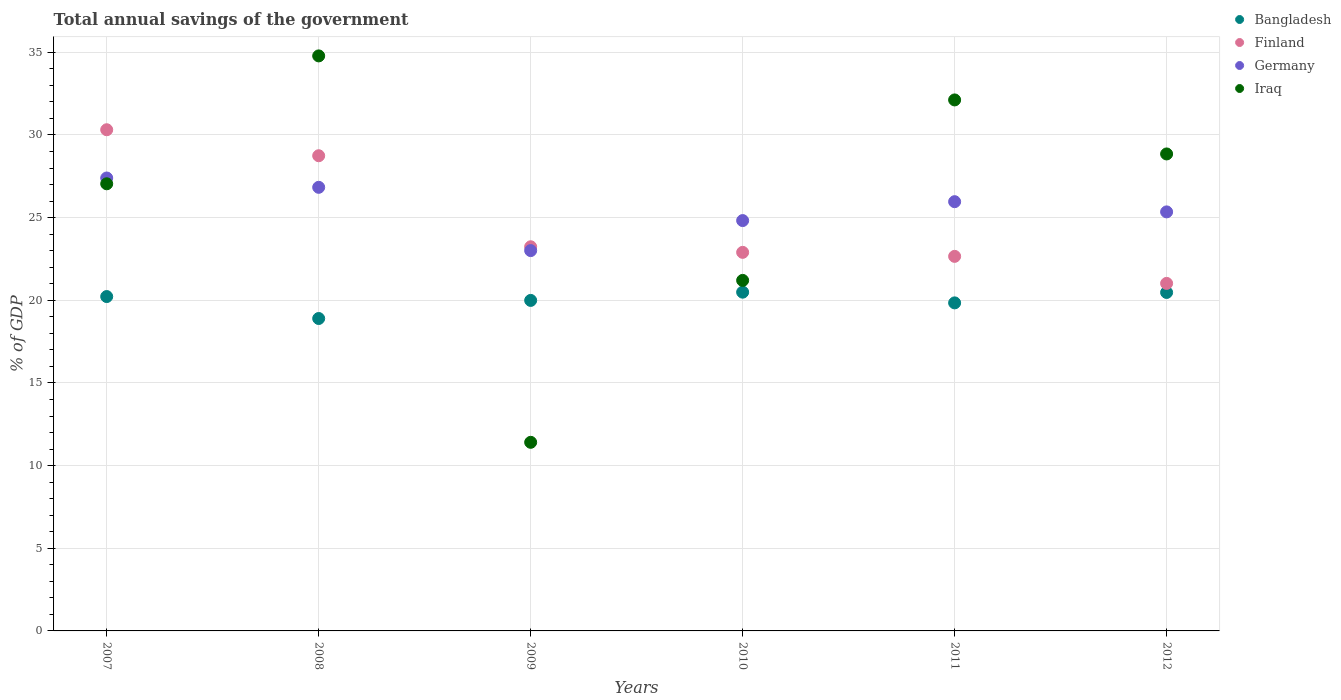How many different coloured dotlines are there?
Offer a very short reply. 4. What is the total annual savings of the government in Finland in 2008?
Your response must be concise. 28.75. Across all years, what is the maximum total annual savings of the government in Iraq?
Your answer should be very brief. 34.79. Across all years, what is the minimum total annual savings of the government in Bangladesh?
Keep it short and to the point. 18.9. In which year was the total annual savings of the government in Bangladesh minimum?
Your response must be concise. 2008. What is the total total annual savings of the government in Iraq in the graph?
Make the answer very short. 155.42. What is the difference between the total annual savings of the government in Bangladesh in 2008 and that in 2010?
Offer a terse response. -1.59. What is the difference between the total annual savings of the government in Iraq in 2010 and the total annual savings of the government in Finland in 2008?
Offer a very short reply. -7.54. What is the average total annual savings of the government in Bangladesh per year?
Ensure brevity in your answer.  19.99. In the year 2010, what is the difference between the total annual savings of the government in Finland and total annual savings of the government in Iraq?
Offer a terse response. 1.7. In how many years, is the total annual savings of the government in Iraq greater than 13 %?
Provide a succinct answer. 5. What is the ratio of the total annual savings of the government in Iraq in 2008 to that in 2010?
Give a very brief answer. 1.64. What is the difference between the highest and the second highest total annual savings of the government in Iraq?
Provide a short and direct response. 2.66. What is the difference between the highest and the lowest total annual savings of the government in Finland?
Offer a very short reply. 9.29. How many years are there in the graph?
Your answer should be very brief. 6. Where does the legend appear in the graph?
Provide a succinct answer. Top right. What is the title of the graph?
Your response must be concise. Total annual savings of the government. Does "Fragile and conflict affected situations" appear as one of the legend labels in the graph?
Make the answer very short. No. What is the label or title of the X-axis?
Your answer should be very brief. Years. What is the label or title of the Y-axis?
Make the answer very short. % of GDP. What is the % of GDP in Bangladesh in 2007?
Keep it short and to the point. 20.23. What is the % of GDP in Finland in 2007?
Ensure brevity in your answer.  30.32. What is the % of GDP in Germany in 2007?
Give a very brief answer. 27.4. What is the % of GDP of Iraq in 2007?
Offer a terse response. 27.05. What is the % of GDP of Bangladesh in 2008?
Your answer should be very brief. 18.9. What is the % of GDP in Finland in 2008?
Ensure brevity in your answer.  28.75. What is the % of GDP in Germany in 2008?
Ensure brevity in your answer.  26.83. What is the % of GDP in Iraq in 2008?
Offer a very short reply. 34.79. What is the % of GDP of Bangladesh in 2009?
Make the answer very short. 19.99. What is the % of GDP of Finland in 2009?
Provide a succinct answer. 23.24. What is the % of GDP of Germany in 2009?
Your answer should be compact. 23.01. What is the % of GDP in Iraq in 2009?
Your answer should be compact. 11.41. What is the % of GDP in Bangladesh in 2010?
Give a very brief answer. 20.49. What is the % of GDP of Finland in 2010?
Keep it short and to the point. 22.9. What is the % of GDP of Germany in 2010?
Keep it short and to the point. 24.82. What is the % of GDP in Iraq in 2010?
Provide a short and direct response. 21.2. What is the % of GDP in Bangladesh in 2011?
Your answer should be very brief. 19.84. What is the % of GDP in Finland in 2011?
Make the answer very short. 22.66. What is the % of GDP of Germany in 2011?
Offer a terse response. 25.97. What is the % of GDP of Iraq in 2011?
Offer a very short reply. 32.12. What is the % of GDP of Bangladesh in 2012?
Provide a short and direct response. 20.47. What is the % of GDP in Finland in 2012?
Offer a very short reply. 21.02. What is the % of GDP of Germany in 2012?
Ensure brevity in your answer.  25.35. What is the % of GDP of Iraq in 2012?
Your answer should be very brief. 28.85. Across all years, what is the maximum % of GDP of Bangladesh?
Offer a very short reply. 20.49. Across all years, what is the maximum % of GDP of Finland?
Make the answer very short. 30.32. Across all years, what is the maximum % of GDP in Germany?
Offer a very short reply. 27.4. Across all years, what is the maximum % of GDP of Iraq?
Give a very brief answer. 34.79. Across all years, what is the minimum % of GDP in Bangladesh?
Ensure brevity in your answer.  18.9. Across all years, what is the minimum % of GDP in Finland?
Give a very brief answer. 21.02. Across all years, what is the minimum % of GDP in Germany?
Make the answer very short. 23.01. Across all years, what is the minimum % of GDP in Iraq?
Provide a short and direct response. 11.41. What is the total % of GDP in Bangladesh in the graph?
Your answer should be very brief. 119.93. What is the total % of GDP of Finland in the graph?
Your answer should be very brief. 148.88. What is the total % of GDP of Germany in the graph?
Offer a terse response. 153.38. What is the total % of GDP in Iraq in the graph?
Offer a very short reply. 155.42. What is the difference between the % of GDP of Bangladesh in 2007 and that in 2008?
Provide a succinct answer. 1.33. What is the difference between the % of GDP in Finland in 2007 and that in 2008?
Provide a succinct answer. 1.57. What is the difference between the % of GDP in Germany in 2007 and that in 2008?
Keep it short and to the point. 0.56. What is the difference between the % of GDP in Iraq in 2007 and that in 2008?
Provide a short and direct response. -7.74. What is the difference between the % of GDP of Bangladesh in 2007 and that in 2009?
Your answer should be very brief. 0.23. What is the difference between the % of GDP in Finland in 2007 and that in 2009?
Ensure brevity in your answer.  7.08. What is the difference between the % of GDP in Germany in 2007 and that in 2009?
Your answer should be very brief. 4.39. What is the difference between the % of GDP of Iraq in 2007 and that in 2009?
Your answer should be very brief. 15.64. What is the difference between the % of GDP of Bangladesh in 2007 and that in 2010?
Your response must be concise. -0.27. What is the difference between the % of GDP in Finland in 2007 and that in 2010?
Offer a very short reply. 7.42. What is the difference between the % of GDP in Germany in 2007 and that in 2010?
Your response must be concise. 2.58. What is the difference between the % of GDP of Iraq in 2007 and that in 2010?
Offer a very short reply. 5.84. What is the difference between the % of GDP of Bangladesh in 2007 and that in 2011?
Your answer should be compact. 0.38. What is the difference between the % of GDP of Finland in 2007 and that in 2011?
Make the answer very short. 7.66. What is the difference between the % of GDP of Germany in 2007 and that in 2011?
Your answer should be very brief. 1.43. What is the difference between the % of GDP of Iraq in 2007 and that in 2011?
Make the answer very short. -5.07. What is the difference between the % of GDP in Bangladesh in 2007 and that in 2012?
Your answer should be very brief. -0.25. What is the difference between the % of GDP of Finland in 2007 and that in 2012?
Ensure brevity in your answer.  9.29. What is the difference between the % of GDP in Germany in 2007 and that in 2012?
Provide a succinct answer. 2.05. What is the difference between the % of GDP in Iraq in 2007 and that in 2012?
Give a very brief answer. -1.81. What is the difference between the % of GDP in Bangladesh in 2008 and that in 2009?
Provide a short and direct response. -1.09. What is the difference between the % of GDP in Finland in 2008 and that in 2009?
Provide a succinct answer. 5.51. What is the difference between the % of GDP of Germany in 2008 and that in 2009?
Provide a short and direct response. 3.83. What is the difference between the % of GDP of Iraq in 2008 and that in 2009?
Offer a very short reply. 23.38. What is the difference between the % of GDP of Bangladesh in 2008 and that in 2010?
Your answer should be compact. -1.59. What is the difference between the % of GDP in Finland in 2008 and that in 2010?
Offer a terse response. 5.84. What is the difference between the % of GDP of Germany in 2008 and that in 2010?
Provide a succinct answer. 2.01. What is the difference between the % of GDP of Iraq in 2008 and that in 2010?
Your response must be concise. 13.58. What is the difference between the % of GDP of Bangladesh in 2008 and that in 2011?
Provide a short and direct response. -0.95. What is the difference between the % of GDP in Finland in 2008 and that in 2011?
Your response must be concise. 6.09. What is the difference between the % of GDP in Germany in 2008 and that in 2011?
Offer a terse response. 0.87. What is the difference between the % of GDP in Iraq in 2008 and that in 2011?
Make the answer very short. 2.66. What is the difference between the % of GDP in Bangladesh in 2008 and that in 2012?
Your answer should be compact. -1.58. What is the difference between the % of GDP in Finland in 2008 and that in 2012?
Your answer should be compact. 7.72. What is the difference between the % of GDP of Germany in 2008 and that in 2012?
Offer a very short reply. 1.49. What is the difference between the % of GDP of Iraq in 2008 and that in 2012?
Offer a terse response. 5.93. What is the difference between the % of GDP of Bangladesh in 2009 and that in 2010?
Offer a terse response. -0.5. What is the difference between the % of GDP in Finland in 2009 and that in 2010?
Give a very brief answer. 0.34. What is the difference between the % of GDP in Germany in 2009 and that in 2010?
Make the answer very short. -1.82. What is the difference between the % of GDP in Iraq in 2009 and that in 2010?
Offer a terse response. -9.79. What is the difference between the % of GDP in Bangladesh in 2009 and that in 2011?
Your answer should be very brief. 0.15. What is the difference between the % of GDP in Finland in 2009 and that in 2011?
Your answer should be very brief. 0.58. What is the difference between the % of GDP of Germany in 2009 and that in 2011?
Provide a short and direct response. -2.96. What is the difference between the % of GDP in Iraq in 2009 and that in 2011?
Make the answer very short. -20.71. What is the difference between the % of GDP in Bangladesh in 2009 and that in 2012?
Ensure brevity in your answer.  -0.48. What is the difference between the % of GDP of Finland in 2009 and that in 2012?
Your answer should be compact. 2.21. What is the difference between the % of GDP in Germany in 2009 and that in 2012?
Provide a short and direct response. -2.34. What is the difference between the % of GDP in Iraq in 2009 and that in 2012?
Offer a terse response. -17.44. What is the difference between the % of GDP of Bangladesh in 2010 and that in 2011?
Provide a short and direct response. 0.65. What is the difference between the % of GDP of Finland in 2010 and that in 2011?
Make the answer very short. 0.24. What is the difference between the % of GDP of Germany in 2010 and that in 2011?
Your response must be concise. -1.14. What is the difference between the % of GDP in Iraq in 2010 and that in 2011?
Your answer should be very brief. -10.92. What is the difference between the % of GDP in Bangladesh in 2010 and that in 2012?
Give a very brief answer. 0.02. What is the difference between the % of GDP in Finland in 2010 and that in 2012?
Your answer should be very brief. 1.88. What is the difference between the % of GDP in Germany in 2010 and that in 2012?
Your answer should be compact. -0.53. What is the difference between the % of GDP in Iraq in 2010 and that in 2012?
Your response must be concise. -7.65. What is the difference between the % of GDP of Bangladesh in 2011 and that in 2012?
Offer a terse response. -0.63. What is the difference between the % of GDP in Finland in 2011 and that in 2012?
Ensure brevity in your answer.  1.64. What is the difference between the % of GDP in Germany in 2011 and that in 2012?
Ensure brevity in your answer.  0.62. What is the difference between the % of GDP in Iraq in 2011 and that in 2012?
Give a very brief answer. 3.27. What is the difference between the % of GDP in Bangladesh in 2007 and the % of GDP in Finland in 2008?
Your response must be concise. -8.52. What is the difference between the % of GDP of Bangladesh in 2007 and the % of GDP of Germany in 2008?
Offer a very short reply. -6.61. What is the difference between the % of GDP of Bangladesh in 2007 and the % of GDP of Iraq in 2008?
Ensure brevity in your answer.  -14.56. What is the difference between the % of GDP in Finland in 2007 and the % of GDP in Germany in 2008?
Your response must be concise. 3.48. What is the difference between the % of GDP in Finland in 2007 and the % of GDP in Iraq in 2008?
Offer a terse response. -4.47. What is the difference between the % of GDP in Germany in 2007 and the % of GDP in Iraq in 2008?
Provide a short and direct response. -7.39. What is the difference between the % of GDP of Bangladesh in 2007 and the % of GDP of Finland in 2009?
Make the answer very short. -3.01. What is the difference between the % of GDP of Bangladesh in 2007 and the % of GDP of Germany in 2009?
Your answer should be very brief. -2.78. What is the difference between the % of GDP of Bangladesh in 2007 and the % of GDP of Iraq in 2009?
Provide a succinct answer. 8.82. What is the difference between the % of GDP of Finland in 2007 and the % of GDP of Germany in 2009?
Provide a succinct answer. 7.31. What is the difference between the % of GDP of Finland in 2007 and the % of GDP of Iraq in 2009?
Keep it short and to the point. 18.91. What is the difference between the % of GDP of Germany in 2007 and the % of GDP of Iraq in 2009?
Your answer should be very brief. 15.99. What is the difference between the % of GDP of Bangladesh in 2007 and the % of GDP of Finland in 2010?
Ensure brevity in your answer.  -2.67. What is the difference between the % of GDP of Bangladesh in 2007 and the % of GDP of Germany in 2010?
Ensure brevity in your answer.  -4.6. What is the difference between the % of GDP of Bangladesh in 2007 and the % of GDP of Iraq in 2010?
Your answer should be compact. -0.98. What is the difference between the % of GDP of Finland in 2007 and the % of GDP of Germany in 2010?
Offer a very short reply. 5.49. What is the difference between the % of GDP of Finland in 2007 and the % of GDP of Iraq in 2010?
Make the answer very short. 9.11. What is the difference between the % of GDP in Germany in 2007 and the % of GDP in Iraq in 2010?
Offer a terse response. 6.19. What is the difference between the % of GDP of Bangladesh in 2007 and the % of GDP of Finland in 2011?
Provide a succinct answer. -2.43. What is the difference between the % of GDP of Bangladesh in 2007 and the % of GDP of Germany in 2011?
Keep it short and to the point. -5.74. What is the difference between the % of GDP of Bangladesh in 2007 and the % of GDP of Iraq in 2011?
Ensure brevity in your answer.  -11.89. What is the difference between the % of GDP of Finland in 2007 and the % of GDP of Germany in 2011?
Offer a terse response. 4.35. What is the difference between the % of GDP in Finland in 2007 and the % of GDP in Iraq in 2011?
Make the answer very short. -1.8. What is the difference between the % of GDP in Germany in 2007 and the % of GDP in Iraq in 2011?
Offer a terse response. -4.72. What is the difference between the % of GDP of Bangladesh in 2007 and the % of GDP of Finland in 2012?
Your answer should be compact. -0.8. What is the difference between the % of GDP of Bangladesh in 2007 and the % of GDP of Germany in 2012?
Your answer should be very brief. -5.12. What is the difference between the % of GDP of Bangladesh in 2007 and the % of GDP of Iraq in 2012?
Give a very brief answer. -8.63. What is the difference between the % of GDP in Finland in 2007 and the % of GDP in Germany in 2012?
Offer a terse response. 4.97. What is the difference between the % of GDP in Finland in 2007 and the % of GDP in Iraq in 2012?
Offer a very short reply. 1.46. What is the difference between the % of GDP of Germany in 2007 and the % of GDP of Iraq in 2012?
Your answer should be compact. -1.46. What is the difference between the % of GDP of Bangladesh in 2008 and the % of GDP of Finland in 2009?
Provide a short and direct response. -4.34. What is the difference between the % of GDP of Bangladesh in 2008 and the % of GDP of Germany in 2009?
Provide a succinct answer. -4.11. What is the difference between the % of GDP of Bangladesh in 2008 and the % of GDP of Iraq in 2009?
Provide a short and direct response. 7.49. What is the difference between the % of GDP of Finland in 2008 and the % of GDP of Germany in 2009?
Your answer should be compact. 5.74. What is the difference between the % of GDP of Finland in 2008 and the % of GDP of Iraq in 2009?
Provide a succinct answer. 17.34. What is the difference between the % of GDP in Germany in 2008 and the % of GDP in Iraq in 2009?
Keep it short and to the point. 15.43. What is the difference between the % of GDP in Bangladesh in 2008 and the % of GDP in Finland in 2010?
Give a very brief answer. -4. What is the difference between the % of GDP in Bangladesh in 2008 and the % of GDP in Germany in 2010?
Provide a succinct answer. -5.92. What is the difference between the % of GDP in Bangladesh in 2008 and the % of GDP in Iraq in 2010?
Your response must be concise. -2.31. What is the difference between the % of GDP of Finland in 2008 and the % of GDP of Germany in 2010?
Provide a short and direct response. 3.92. What is the difference between the % of GDP in Finland in 2008 and the % of GDP in Iraq in 2010?
Make the answer very short. 7.54. What is the difference between the % of GDP of Germany in 2008 and the % of GDP of Iraq in 2010?
Ensure brevity in your answer.  5.63. What is the difference between the % of GDP in Bangladesh in 2008 and the % of GDP in Finland in 2011?
Provide a short and direct response. -3.76. What is the difference between the % of GDP of Bangladesh in 2008 and the % of GDP of Germany in 2011?
Provide a succinct answer. -7.07. What is the difference between the % of GDP of Bangladesh in 2008 and the % of GDP of Iraq in 2011?
Your answer should be compact. -13.22. What is the difference between the % of GDP in Finland in 2008 and the % of GDP in Germany in 2011?
Make the answer very short. 2.78. What is the difference between the % of GDP of Finland in 2008 and the % of GDP of Iraq in 2011?
Offer a very short reply. -3.38. What is the difference between the % of GDP in Germany in 2008 and the % of GDP in Iraq in 2011?
Your answer should be compact. -5.29. What is the difference between the % of GDP of Bangladesh in 2008 and the % of GDP of Finland in 2012?
Your response must be concise. -2.12. What is the difference between the % of GDP in Bangladesh in 2008 and the % of GDP in Germany in 2012?
Provide a succinct answer. -6.45. What is the difference between the % of GDP of Bangladesh in 2008 and the % of GDP of Iraq in 2012?
Your answer should be very brief. -9.95. What is the difference between the % of GDP of Finland in 2008 and the % of GDP of Germany in 2012?
Make the answer very short. 3.4. What is the difference between the % of GDP of Finland in 2008 and the % of GDP of Iraq in 2012?
Keep it short and to the point. -0.11. What is the difference between the % of GDP of Germany in 2008 and the % of GDP of Iraq in 2012?
Your answer should be compact. -2.02. What is the difference between the % of GDP of Bangladesh in 2009 and the % of GDP of Finland in 2010?
Provide a short and direct response. -2.91. What is the difference between the % of GDP of Bangladesh in 2009 and the % of GDP of Germany in 2010?
Offer a very short reply. -4.83. What is the difference between the % of GDP in Bangladesh in 2009 and the % of GDP in Iraq in 2010?
Your answer should be compact. -1.21. What is the difference between the % of GDP in Finland in 2009 and the % of GDP in Germany in 2010?
Offer a very short reply. -1.58. What is the difference between the % of GDP of Finland in 2009 and the % of GDP of Iraq in 2010?
Offer a terse response. 2.03. What is the difference between the % of GDP of Germany in 2009 and the % of GDP of Iraq in 2010?
Offer a terse response. 1.8. What is the difference between the % of GDP in Bangladesh in 2009 and the % of GDP in Finland in 2011?
Offer a very short reply. -2.66. What is the difference between the % of GDP of Bangladesh in 2009 and the % of GDP of Germany in 2011?
Make the answer very short. -5.97. What is the difference between the % of GDP in Bangladesh in 2009 and the % of GDP in Iraq in 2011?
Your response must be concise. -12.13. What is the difference between the % of GDP of Finland in 2009 and the % of GDP of Germany in 2011?
Offer a terse response. -2.73. What is the difference between the % of GDP of Finland in 2009 and the % of GDP of Iraq in 2011?
Your response must be concise. -8.88. What is the difference between the % of GDP of Germany in 2009 and the % of GDP of Iraq in 2011?
Your answer should be compact. -9.11. What is the difference between the % of GDP in Bangladesh in 2009 and the % of GDP in Finland in 2012?
Your response must be concise. -1.03. What is the difference between the % of GDP in Bangladesh in 2009 and the % of GDP in Germany in 2012?
Ensure brevity in your answer.  -5.36. What is the difference between the % of GDP in Bangladesh in 2009 and the % of GDP in Iraq in 2012?
Your answer should be very brief. -8.86. What is the difference between the % of GDP of Finland in 2009 and the % of GDP of Germany in 2012?
Your answer should be compact. -2.11. What is the difference between the % of GDP in Finland in 2009 and the % of GDP in Iraq in 2012?
Your response must be concise. -5.62. What is the difference between the % of GDP in Germany in 2009 and the % of GDP in Iraq in 2012?
Ensure brevity in your answer.  -5.85. What is the difference between the % of GDP of Bangladesh in 2010 and the % of GDP of Finland in 2011?
Ensure brevity in your answer.  -2.17. What is the difference between the % of GDP in Bangladesh in 2010 and the % of GDP in Germany in 2011?
Your answer should be very brief. -5.47. What is the difference between the % of GDP of Bangladesh in 2010 and the % of GDP of Iraq in 2011?
Make the answer very short. -11.63. What is the difference between the % of GDP in Finland in 2010 and the % of GDP in Germany in 2011?
Your answer should be very brief. -3.07. What is the difference between the % of GDP of Finland in 2010 and the % of GDP of Iraq in 2011?
Provide a short and direct response. -9.22. What is the difference between the % of GDP of Germany in 2010 and the % of GDP of Iraq in 2011?
Give a very brief answer. -7.3. What is the difference between the % of GDP of Bangladesh in 2010 and the % of GDP of Finland in 2012?
Keep it short and to the point. -0.53. What is the difference between the % of GDP in Bangladesh in 2010 and the % of GDP in Germany in 2012?
Make the answer very short. -4.86. What is the difference between the % of GDP in Bangladesh in 2010 and the % of GDP in Iraq in 2012?
Your answer should be compact. -8.36. What is the difference between the % of GDP in Finland in 2010 and the % of GDP in Germany in 2012?
Ensure brevity in your answer.  -2.45. What is the difference between the % of GDP in Finland in 2010 and the % of GDP in Iraq in 2012?
Your answer should be very brief. -5.95. What is the difference between the % of GDP in Germany in 2010 and the % of GDP in Iraq in 2012?
Give a very brief answer. -4.03. What is the difference between the % of GDP of Bangladesh in 2011 and the % of GDP of Finland in 2012?
Give a very brief answer. -1.18. What is the difference between the % of GDP of Bangladesh in 2011 and the % of GDP of Germany in 2012?
Offer a very short reply. -5.5. What is the difference between the % of GDP in Bangladesh in 2011 and the % of GDP in Iraq in 2012?
Offer a terse response. -9.01. What is the difference between the % of GDP of Finland in 2011 and the % of GDP of Germany in 2012?
Your answer should be compact. -2.69. What is the difference between the % of GDP in Finland in 2011 and the % of GDP in Iraq in 2012?
Your answer should be compact. -6.2. What is the difference between the % of GDP of Germany in 2011 and the % of GDP of Iraq in 2012?
Offer a terse response. -2.89. What is the average % of GDP in Bangladesh per year?
Make the answer very short. 19.99. What is the average % of GDP of Finland per year?
Give a very brief answer. 24.81. What is the average % of GDP of Germany per year?
Ensure brevity in your answer.  25.56. What is the average % of GDP of Iraq per year?
Make the answer very short. 25.9. In the year 2007, what is the difference between the % of GDP in Bangladesh and % of GDP in Finland?
Your answer should be very brief. -10.09. In the year 2007, what is the difference between the % of GDP of Bangladesh and % of GDP of Germany?
Make the answer very short. -7.17. In the year 2007, what is the difference between the % of GDP of Bangladesh and % of GDP of Iraq?
Give a very brief answer. -6.82. In the year 2007, what is the difference between the % of GDP in Finland and % of GDP in Germany?
Ensure brevity in your answer.  2.92. In the year 2007, what is the difference between the % of GDP of Finland and % of GDP of Iraq?
Offer a terse response. 3.27. In the year 2007, what is the difference between the % of GDP in Germany and % of GDP in Iraq?
Provide a short and direct response. 0.35. In the year 2008, what is the difference between the % of GDP of Bangladesh and % of GDP of Finland?
Provide a succinct answer. -9.85. In the year 2008, what is the difference between the % of GDP in Bangladesh and % of GDP in Germany?
Ensure brevity in your answer.  -7.94. In the year 2008, what is the difference between the % of GDP in Bangladesh and % of GDP in Iraq?
Make the answer very short. -15.89. In the year 2008, what is the difference between the % of GDP in Finland and % of GDP in Germany?
Your answer should be very brief. 1.91. In the year 2008, what is the difference between the % of GDP of Finland and % of GDP of Iraq?
Your answer should be compact. -6.04. In the year 2008, what is the difference between the % of GDP in Germany and % of GDP in Iraq?
Your answer should be very brief. -7.95. In the year 2009, what is the difference between the % of GDP of Bangladesh and % of GDP of Finland?
Offer a terse response. -3.24. In the year 2009, what is the difference between the % of GDP of Bangladesh and % of GDP of Germany?
Provide a succinct answer. -3.01. In the year 2009, what is the difference between the % of GDP in Bangladesh and % of GDP in Iraq?
Your answer should be compact. 8.58. In the year 2009, what is the difference between the % of GDP of Finland and % of GDP of Germany?
Your answer should be compact. 0.23. In the year 2009, what is the difference between the % of GDP in Finland and % of GDP in Iraq?
Your response must be concise. 11.83. In the year 2009, what is the difference between the % of GDP of Germany and % of GDP of Iraq?
Keep it short and to the point. 11.6. In the year 2010, what is the difference between the % of GDP in Bangladesh and % of GDP in Finland?
Make the answer very short. -2.41. In the year 2010, what is the difference between the % of GDP in Bangladesh and % of GDP in Germany?
Ensure brevity in your answer.  -4.33. In the year 2010, what is the difference between the % of GDP in Bangladesh and % of GDP in Iraq?
Ensure brevity in your answer.  -0.71. In the year 2010, what is the difference between the % of GDP in Finland and % of GDP in Germany?
Keep it short and to the point. -1.92. In the year 2010, what is the difference between the % of GDP in Finland and % of GDP in Iraq?
Make the answer very short. 1.7. In the year 2010, what is the difference between the % of GDP in Germany and % of GDP in Iraq?
Your answer should be compact. 3.62. In the year 2011, what is the difference between the % of GDP of Bangladesh and % of GDP of Finland?
Give a very brief answer. -2.81. In the year 2011, what is the difference between the % of GDP in Bangladesh and % of GDP in Germany?
Provide a succinct answer. -6.12. In the year 2011, what is the difference between the % of GDP of Bangladesh and % of GDP of Iraq?
Provide a short and direct response. -12.28. In the year 2011, what is the difference between the % of GDP of Finland and % of GDP of Germany?
Your answer should be very brief. -3.31. In the year 2011, what is the difference between the % of GDP in Finland and % of GDP in Iraq?
Your answer should be compact. -9.46. In the year 2011, what is the difference between the % of GDP in Germany and % of GDP in Iraq?
Provide a succinct answer. -6.16. In the year 2012, what is the difference between the % of GDP of Bangladesh and % of GDP of Finland?
Ensure brevity in your answer.  -0.55. In the year 2012, what is the difference between the % of GDP in Bangladesh and % of GDP in Germany?
Provide a succinct answer. -4.87. In the year 2012, what is the difference between the % of GDP in Bangladesh and % of GDP in Iraq?
Keep it short and to the point. -8.38. In the year 2012, what is the difference between the % of GDP in Finland and % of GDP in Germany?
Keep it short and to the point. -4.33. In the year 2012, what is the difference between the % of GDP in Finland and % of GDP in Iraq?
Ensure brevity in your answer.  -7.83. In the year 2012, what is the difference between the % of GDP in Germany and % of GDP in Iraq?
Make the answer very short. -3.5. What is the ratio of the % of GDP in Bangladesh in 2007 to that in 2008?
Your answer should be compact. 1.07. What is the ratio of the % of GDP of Finland in 2007 to that in 2008?
Your answer should be compact. 1.05. What is the ratio of the % of GDP in Germany in 2007 to that in 2008?
Provide a succinct answer. 1.02. What is the ratio of the % of GDP in Iraq in 2007 to that in 2008?
Provide a short and direct response. 0.78. What is the ratio of the % of GDP of Bangladesh in 2007 to that in 2009?
Make the answer very short. 1.01. What is the ratio of the % of GDP of Finland in 2007 to that in 2009?
Make the answer very short. 1.3. What is the ratio of the % of GDP in Germany in 2007 to that in 2009?
Keep it short and to the point. 1.19. What is the ratio of the % of GDP in Iraq in 2007 to that in 2009?
Provide a short and direct response. 2.37. What is the ratio of the % of GDP of Bangladesh in 2007 to that in 2010?
Give a very brief answer. 0.99. What is the ratio of the % of GDP of Finland in 2007 to that in 2010?
Provide a succinct answer. 1.32. What is the ratio of the % of GDP of Germany in 2007 to that in 2010?
Make the answer very short. 1.1. What is the ratio of the % of GDP of Iraq in 2007 to that in 2010?
Your answer should be compact. 1.28. What is the ratio of the % of GDP in Bangladesh in 2007 to that in 2011?
Keep it short and to the point. 1.02. What is the ratio of the % of GDP in Finland in 2007 to that in 2011?
Your response must be concise. 1.34. What is the ratio of the % of GDP in Germany in 2007 to that in 2011?
Ensure brevity in your answer.  1.06. What is the ratio of the % of GDP of Iraq in 2007 to that in 2011?
Keep it short and to the point. 0.84. What is the ratio of the % of GDP of Bangladesh in 2007 to that in 2012?
Your answer should be compact. 0.99. What is the ratio of the % of GDP of Finland in 2007 to that in 2012?
Make the answer very short. 1.44. What is the ratio of the % of GDP of Germany in 2007 to that in 2012?
Your answer should be very brief. 1.08. What is the ratio of the % of GDP of Iraq in 2007 to that in 2012?
Give a very brief answer. 0.94. What is the ratio of the % of GDP of Bangladesh in 2008 to that in 2009?
Make the answer very short. 0.95. What is the ratio of the % of GDP in Finland in 2008 to that in 2009?
Offer a terse response. 1.24. What is the ratio of the % of GDP of Germany in 2008 to that in 2009?
Provide a succinct answer. 1.17. What is the ratio of the % of GDP in Iraq in 2008 to that in 2009?
Make the answer very short. 3.05. What is the ratio of the % of GDP in Bangladesh in 2008 to that in 2010?
Keep it short and to the point. 0.92. What is the ratio of the % of GDP of Finland in 2008 to that in 2010?
Provide a short and direct response. 1.26. What is the ratio of the % of GDP of Germany in 2008 to that in 2010?
Your answer should be compact. 1.08. What is the ratio of the % of GDP in Iraq in 2008 to that in 2010?
Make the answer very short. 1.64. What is the ratio of the % of GDP of Finland in 2008 to that in 2011?
Your response must be concise. 1.27. What is the ratio of the % of GDP in Germany in 2008 to that in 2011?
Your response must be concise. 1.03. What is the ratio of the % of GDP in Iraq in 2008 to that in 2011?
Give a very brief answer. 1.08. What is the ratio of the % of GDP of Bangladesh in 2008 to that in 2012?
Your answer should be very brief. 0.92. What is the ratio of the % of GDP of Finland in 2008 to that in 2012?
Your answer should be compact. 1.37. What is the ratio of the % of GDP of Germany in 2008 to that in 2012?
Ensure brevity in your answer.  1.06. What is the ratio of the % of GDP in Iraq in 2008 to that in 2012?
Provide a succinct answer. 1.21. What is the ratio of the % of GDP of Bangladesh in 2009 to that in 2010?
Your answer should be very brief. 0.98. What is the ratio of the % of GDP of Finland in 2009 to that in 2010?
Ensure brevity in your answer.  1.01. What is the ratio of the % of GDP of Germany in 2009 to that in 2010?
Make the answer very short. 0.93. What is the ratio of the % of GDP of Iraq in 2009 to that in 2010?
Your answer should be very brief. 0.54. What is the ratio of the % of GDP of Bangladesh in 2009 to that in 2011?
Your response must be concise. 1.01. What is the ratio of the % of GDP of Finland in 2009 to that in 2011?
Give a very brief answer. 1.03. What is the ratio of the % of GDP of Germany in 2009 to that in 2011?
Keep it short and to the point. 0.89. What is the ratio of the % of GDP of Iraq in 2009 to that in 2011?
Your answer should be very brief. 0.36. What is the ratio of the % of GDP in Bangladesh in 2009 to that in 2012?
Make the answer very short. 0.98. What is the ratio of the % of GDP of Finland in 2009 to that in 2012?
Keep it short and to the point. 1.11. What is the ratio of the % of GDP in Germany in 2009 to that in 2012?
Provide a succinct answer. 0.91. What is the ratio of the % of GDP in Iraq in 2009 to that in 2012?
Ensure brevity in your answer.  0.4. What is the ratio of the % of GDP of Bangladesh in 2010 to that in 2011?
Make the answer very short. 1.03. What is the ratio of the % of GDP in Finland in 2010 to that in 2011?
Your answer should be compact. 1.01. What is the ratio of the % of GDP in Germany in 2010 to that in 2011?
Provide a short and direct response. 0.96. What is the ratio of the % of GDP of Iraq in 2010 to that in 2011?
Make the answer very short. 0.66. What is the ratio of the % of GDP of Finland in 2010 to that in 2012?
Give a very brief answer. 1.09. What is the ratio of the % of GDP in Germany in 2010 to that in 2012?
Make the answer very short. 0.98. What is the ratio of the % of GDP of Iraq in 2010 to that in 2012?
Give a very brief answer. 0.73. What is the ratio of the % of GDP of Bangladesh in 2011 to that in 2012?
Offer a very short reply. 0.97. What is the ratio of the % of GDP of Finland in 2011 to that in 2012?
Your response must be concise. 1.08. What is the ratio of the % of GDP in Germany in 2011 to that in 2012?
Ensure brevity in your answer.  1.02. What is the ratio of the % of GDP in Iraq in 2011 to that in 2012?
Keep it short and to the point. 1.11. What is the difference between the highest and the second highest % of GDP in Bangladesh?
Give a very brief answer. 0.02. What is the difference between the highest and the second highest % of GDP in Finland?
Your response must be concise. 1.57. What is the difference between the highest and the second highest % of GDP of Germany?
Give a very brief answer. 0.56. What is the difference between the highest and the second highest % of GDP in Iraq?
Your response must be concise. 2.66. What is the difference between the highest and the lowest % of GDP in Bangladesh?
Provide a short and direct response. 1.59. What is the difference between the highest and the lowest % of GDP of Finland?
Give a very brief answer. 9.29. What is the difference between the highest and the lowest % of GDP of Germany?
Offer a very short reply. 4.39. What is the difference between the highest and the lowest % of GDP in Iraq?
Keep it short and to the point. 23.38. 